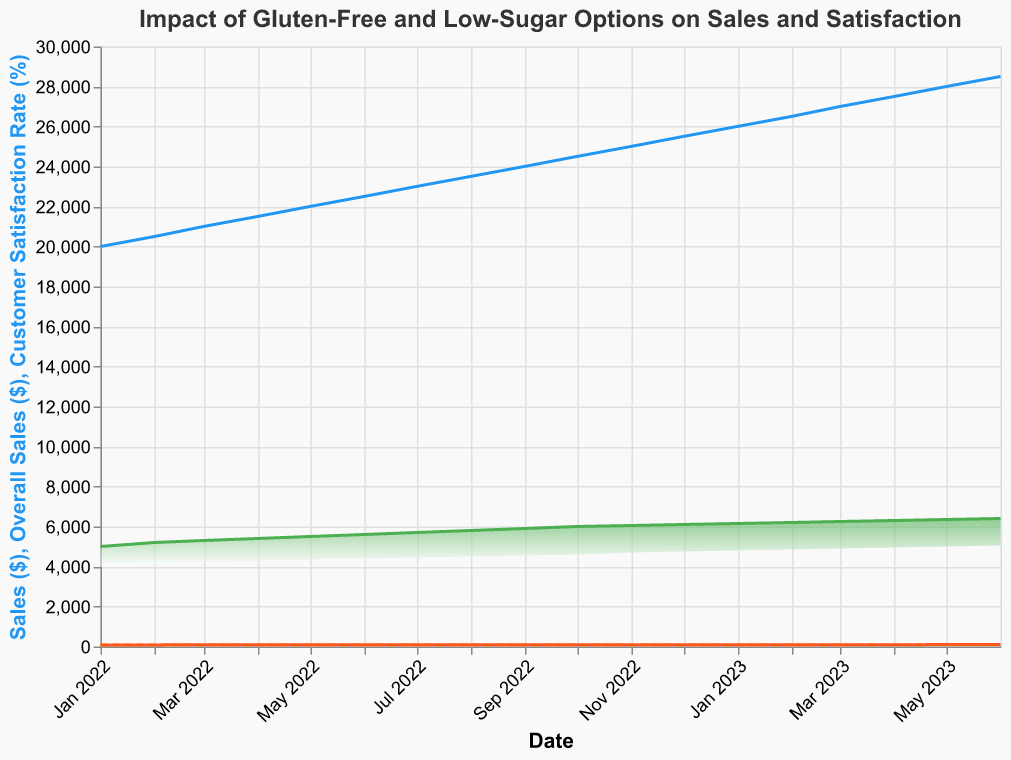What is the title of the chart? The title is usually located at the top of the chart and is intended to give a summary of the content.
Answer: Impact of Gluten-Free and Low-Sugar Options on Sales and Satisfaction How do the sales of gluten-free and low-sugar options compare in January 2022? To compare the sales in January 2022, look at the height of the areas for "Gluten-Free Sales" and "Low-Sugar Sales".
Answer: Gluten-Free: $5000, Low-Sugar: $4000 What trend can be observed in overall sales over the specified period? The overall sales are represented by the blue line. Observe if it is increasing, decreasing, or staying constant over time.
Answer: Increasing How much did the customer satisfaction rate (post-introduction) increase from January 2022 to June 2023? Find the customer satisfaction rate for January 2022 and June 2023, then subtract the earlier value from the later value. January 2022 is 80 and June 2023 is 95. Calculate the increase: 95 - 80 = 15.
Answer: 15% When did gluten-free sales first hit $6000? Look at the timeline and find the date when the green area representing "Gluten-Free Sales" reaches $6000.
Answer: October 2022 What is the difference in the rate of customer satisfaction pre- and post-introduction in June 2023? Locate the customer satisfaction rate for June 2023 for both pre- and post-introduction. Subtract the pre-introduction rate from the post-introduction rate. 95 (post) - 82 (pre) = 13.
Answer: 13% How do the customer satisfaction rates pre- and post-introduction compare in December 2022? Look at the customer satisfaction rates for December 2022 for both pre- and post-introduction.
Answer: Pre: 81, Post: 90 Which month shows the highest increase in customer satisfaction post-introduction? Identify the points where the post-introduction line shows the greatest upward movement compared to the previous month.
Answer: May 2023 What is the lowest monthly sales figure for low-sugar options in 2022? Find the lowest point of the "Low-Sugar Sales" area for each month in 2022. The lowest point is February 2022 with $4100.
Answer: $4100 What are the colors used to represent overall sales and post-introduction customer satisfaction rates? Identify the line colors for "Overall Sales" and the post-introduction customer satisfaction rate. Overall sales are in blue (#2196F3), and post-introduction satisfaction rate is in orange (#FF5722).
Answer: Overall sales: Blue, Post-introduction satisfaction rate: Orange 